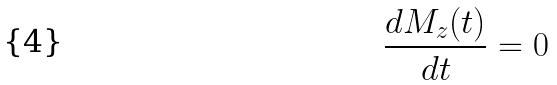<formula> <loc_0><loc_0><loc_500><loc_500>\frac { d M _ { z } ( t ) } { d t } = 0</formula> 